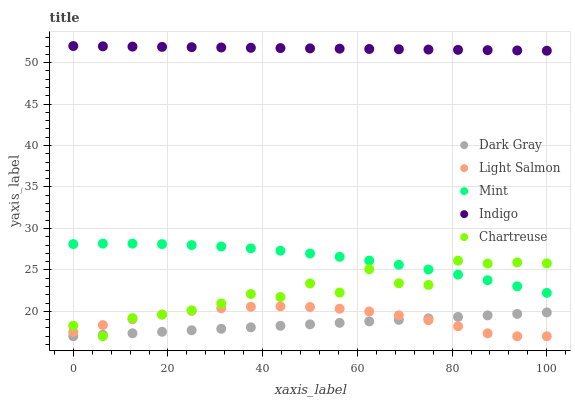Does Dark Gray have the minimum area under the curve?
Answer yes or no. Yes. Does Indigo have the maximum area under the curve?
Answer yes or no. Yes. Does Light Salmon have the minimum area under the curve?
Answer yes or no. No. Does Light Salmon have the maximum area under the curve?
Answer yes or no. No. Is Indigo the smoothest?
Answer yes or no. Yes. Is Chartreuse the roughest?
Answer yes or no. Yes. Is Light Salmon the smoothest?
Answer yes or no. No. Is Light Salmon the roughest?
Answer yes or no. No. Does Dark Gray have the lowest value?
Answer yes or no. Yes. Does Indigo have the lowest value?
Answer yes or no. No. Does Indigo have the highest value?
Answer yes or no. Yes. Does Light Salmon have the highest value?
Answer yes or no. No. Is Light Salmon less than Mint?
Answer yes or no. Yes. Is Indigo greater than Light Salmon?
Answer yes or no. Yes. Does Light Salmon intersect Chartreuse?
Answer yes or no. Yes. Is Light Salmon less than Chartreuse?
Answer yes or no. No. Is Light Salmon greater than Chartreuse?
Answer yes or no. No. Does Light Salmon intersect Mint?
Answer yes or no. No. 